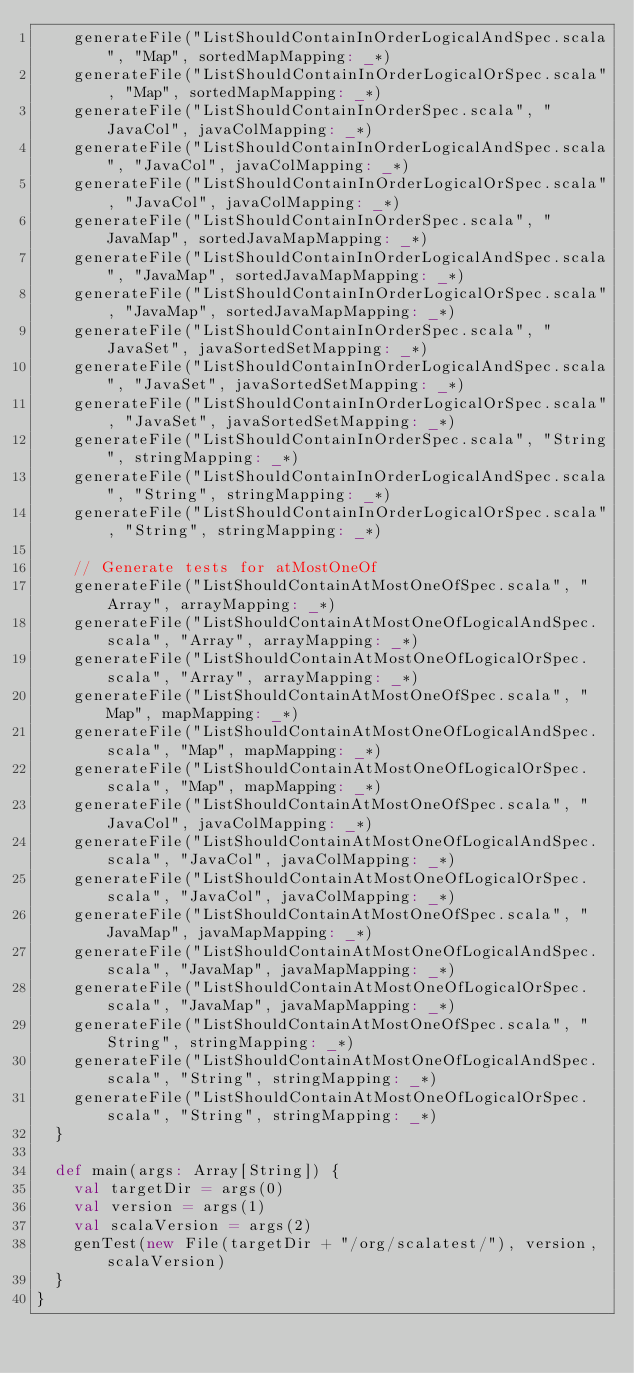<code> <loc_0><loc_0><loc_500><loc_500><_Scala_>    generateFile("ListShouldContainInOrderLogicalAndSpec.scala", "Map", sortedMapMapping: _*)
    generateFile("ListShouldContainInOrderLogicalOrSpec.scala", "Map", sortedMapMapping: _*)
    generateFile("ListShouldContainInOrderSpec.scala", "JavaCol", javaColMapping: _*)
    generateFile("ListShouldContainInOrderLogicalAndSpec.scala", "JavaCol", javaColMapping: _*)
    generateFile("ListShouldContainInOrderLogicalOrSpec.scala", "JavaCol", javaColMapping: _*)
    generateFile("ListShouldContainInOrderSpec.scala", "JavaMap", sortedJavaMapMapping: _*)
    generateFile("ListShouldContainInOrderLogicalAndSpec.scala", "JavaMap", sortedJavaMapMapping: _*)
    generateFile("ListShouldContainInOrderLogicalOrSpec.scala", "JavaMap", sortedJavaMapMapping: _*)
    generateFile("ListShouldContainInOrderSpec.scala", "JavaSet", javaSortedSetMapping: _*)
    generateFile("ListShouldContainInOrderLogicalAndSpec.scala", "JavaSet", javaSortedSetMapping: _*)
    generateFile("ListShouldContainInOrderLogicalOrSpec.scala", "JavaSet", javaSortedSetMapping: _*)
    generateFile("ListShouldContainInOrderSpec.scala", "String", stringMapping: _*)
    generateFile("ListShouldContainInOrderLogicalAndSpec.scala", "String", stringMapping: _*)
    generateFile("ListShouldContainInOrderLogicalOrSpec.scala", "String", stringMapping: _*)

    // Generate tests for atMostOneOf
    generateFile("ListShouldContainAtMostOneOfSpec.scala", "Array", arrayMapping: _*)
    generateFile("ListShouldContainAtMostOneOfLogicalAndSpec.scala", "Array", arrayMapping: _*)
    generateFile("ListShouldContainAtMostOneOfLogicalOrSpec.scala", "Array", arrayMapping: _*)
    generateFile("ListShouldContainAtMostOneOfSpec.scala", "Map", mapMapping: _*)
    generateFile("ListShouldContainAtMostOneOfLogicalAndSpec.scala", "Map", mapMapping: _*)
    generateFile("ListShouldContainAtMostOneOfLogicalOrSpec.scala", "Map", mapMapping: _*)
    generateFile("ListShouldContainAtMostOneOfSpec.scala", "JavaCol", javaColMapping: _*)
    generateFile("ListShouldContainAtMostOneOfLogicalAndSpec.scala", "JavaCol", javaColMapping: _*)
    generateFile("ListShouldContainAtMostOneOfLogicalOrSpec.scala", "JavaCol", javaColMapping: _*)
    generateFile("ListShouldContainAtMostOneOfSpec.scala", "JavaMap", javaMapMapping: _*)
    generateFile("ListShouldContainAtMostOneOfLogicalAndSpec.scala", "JavaMap", javaMapMapping: _*)
    generateFile("ListShouldContainAtMostOneOfLogicalOrSpec.scala", "JavaMap", javaMapMapping: _*)
    generateFile("ListShouldContainAtMostOneOfSpec.scala", "String", stringMapping: _*)
    generateFile("ListShouldContainAtMostOneOfLogicalAndSpec.scala", "String", stringMapping: _*)
    generateFile("ListShouldContainAtMostOneOfLogicalOrSpec.scala", "String", stringMapping: _*)
  }

  def main(args: Array[String]) {
    val targetDir = args(0)
    val version = args(1)
    val scalaVersion = args(2)
    genTest(new File(targetDir + "/org/scalatest/"), version, scalaVersion)
  }
}
</code> 